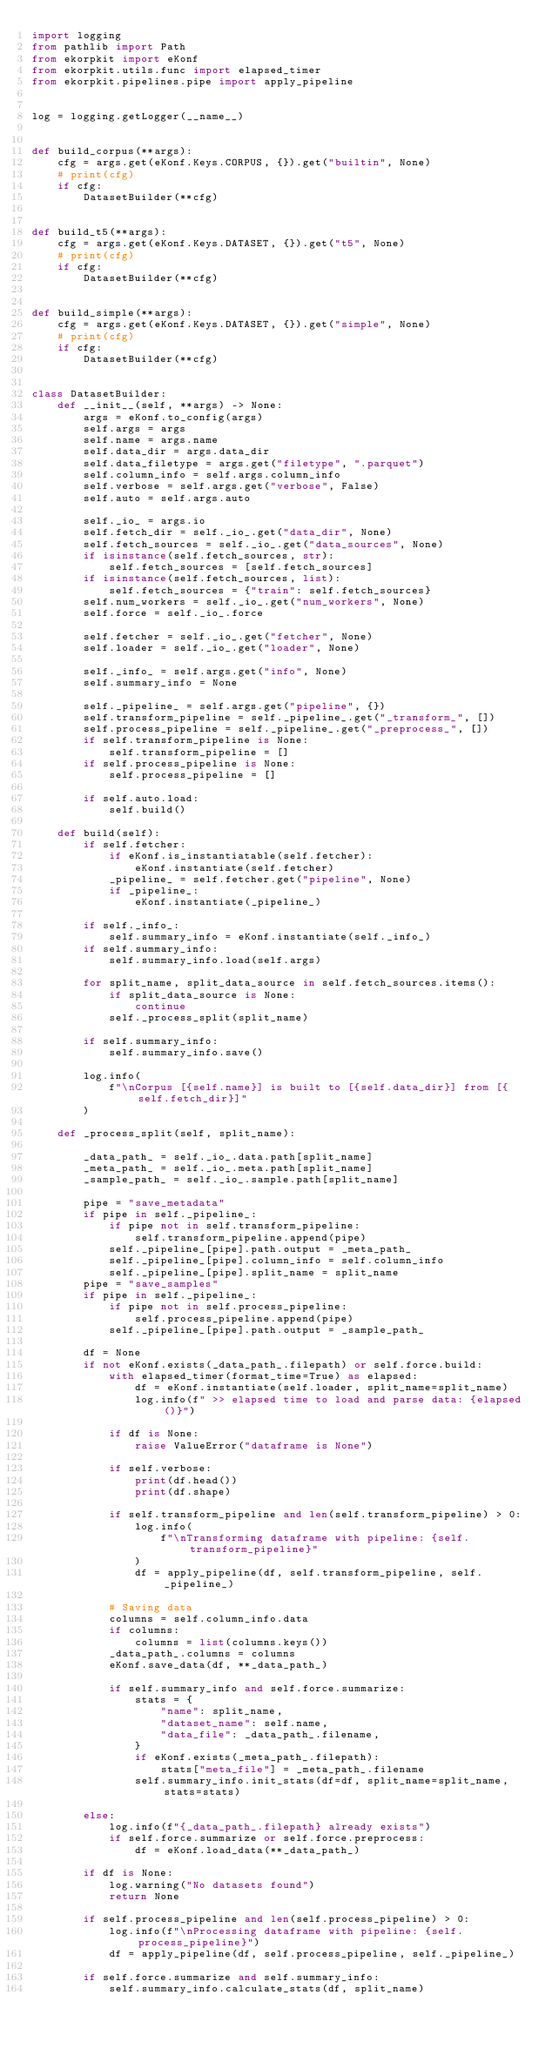<code> <loc_0><loc_0><loc_500><loc_500><_Python_>import logging
from pathlib import Path
from ekorpkit import eKonf
from ekorpkit.utils.func import elapsed_timer
from ekorpkit.pipelines.pipe import apply_pipeline


log = logging.getLogger(__name__)


def build_corpus(**args):
    cfg = args.get(eKonf.Keys.CORPUS, {}).get("builtin", None)
    # print(cfg)
    if cfg:
        DatasetBuilder(**cfg)


def build_t5(**args):
    cfg = args.get(eKonf.Keys.DATASET, {}).get("t5", None)
    # print(cfg)
    if cfg:
        DatasetBuilder(**cfg)


def build_simple(**args):
    cfg = args.get(eKonf.Keys.DATASET, {}).get("simple", None)
    # print(cfg)
    if cfg:
        DatasetBuilder(**cfg)


class DatasetBuilder:
    def __init__(self, **args) -> None:
        args = eKonf.to_config(args)
        self.args = args
        self.name = args.name
        self.data_dir = args.data_dir
        self.data_filetype = args.get("filetype", ".parquet")
        self.column_info = self.args.column_info
        self.verbose = self.args.get("verbose", False)
        self.auto = self.args.auto

        self._io_ = args.io
        self.fetch_dir = self._io_.get("data_dir", None)
        self.fetch_sources = self._io_.get("data_sources", None)
        if isinstance(self.fetch_sources, str):
            self.fetch_sources = [self.fetch_sources]
        if isinstance(self.fetch_sources, list):
            self.fetch_sources = {"train": self.fetch_sources}
        self.num_workers = self._io_.get("num_workers", None)
        self.force = self._io_.force

        self.fetcher = self._io_.get("fetcher", None)
        self.loader = self._io_.get("loader", None)

        self._info_ = self.args.get("info", None)
        self.summary_info = None

        self._pipeline_ = self.args.get("pipeline", {})
        self.transform_pipeline = self._pipeline_.get("_transform_", [])
        self.process_pipeline = self._pipeline_.get("_preprocess_", [])
        if self.transform_pipeline is None:
            self.transform_pipeline = []
        if self.process_pipeline is None:
            self.process_pipeline = []

        if self.auto.load:
            self.build()

    def build(self):
        if self.fetcher:
            if eKonf.is_instantiatable(self.fetcher):
                eKonf.instantiate(self.fetcher)
            _pipeline_ = self.fetcher.get("pipeline", None)
            if _pipeline_:
                eKonf.instantiate(_pipeline_)

        if self._info_:
            self.summary_info = eKonf.instantiate(self._info_)
        if self.summary_info:
            self.summary_info.load(self.args)

        for split_name, split_data_source in self.fetch_sources.items():
            if split_data_source is None:
                continue
            self._process_split(split_name)

        if self.summary_info:
            self.summary_info.save()

        log.info(
            f"\nCorpus [{self.name}] is built to [{self.data_dir}] from [{self.fetch_dir}]"
        )

    def _process_split(self, split_name):

        _data_path_ = self._io_.data.path[split_name]
        _meta_path_ = self._io_.meta.path[split_name]
        _sample_path_ = self._io_.sample.path[split_name]

        pipe = "save_metadata"
        if pipe in self._pipeline_:
            if pipe not in self.transform_pipeline:
                self.transform_pipeline.append(pipe)
            self._pipeline_[pipe].path.output = _meta_path_
            self._pipeline_[pipe].column_info = self.column_info
            self._pipeline_[pipe].split_name = split_name
        pipe = "save_samples"
        if pipe in self._pipeline_:
            if pipe not in self.process_pipeline:
                self.process_pipeline.append(pipe)
            self._pipeline_[pipe].path.output = _sample_path_

        df = None
        if not eKonf.exists(_data_path_.filepath) or self.force.build:
            with elapsed_timer(format_time=True) as elapsed:
                df = eKonf.instantiate(self.loader, split_name=split_name)
                log.info(f" >> elapsed time to load and parse data: {elapsed()}")

            if df is None:
                raise ValueError("dataframe is None")

            if self.verbose:
                print(df.head())
                print(df.shape)

            if self.transform_pipeline and len(self.transform_pipeline) > 0:
                log.info(
                    f"\nTransforming dataframe with pipeline: {self.transform_pipeline}"
                )
                df = apply_pipeline(df, self.transform_pipeline, self._pipeline_)

            # Saving data
            columns = self.column_info.data
            if columns:
                columns = list(columns.keys())
            _data_path_.columns = columns
            eKonf.save_data(df, **_data_path_)

            if self.summary_info and self.force.summarize:
                stats = {
                    "name": split_name,
                    "dataset_name": self.name,
                    "data_file": _data_path_.filename,
                }
                if eKonf.exists(_meta_path_.filepath):
                    stats["meta_file"] = _meta_path_.filename
                self.summary_info.init_stats(df=df, split_name=split_name, stats=stats)

        else:
            log.info(f"{_data_path_.filepath} already exists")
            if self.force.summarize or self.force.preprocess:
                df = eKonf.load_data(**_data_path_)

        if df is None:
            log.warning("No datasets found")
            return None

        if self.process_pipeline and len(self.process_pipeline) > 0:
            log.info(f"\nProcessing dataframe with pipeline: {self.process_pipeline}")
            df = apply_pipeline(df, self.process_pipeline, self._pipeline_)

        if self.force.summarize and self.summary_info:
            self.summary_info.calculate_stats(df, split_name)
</code> 